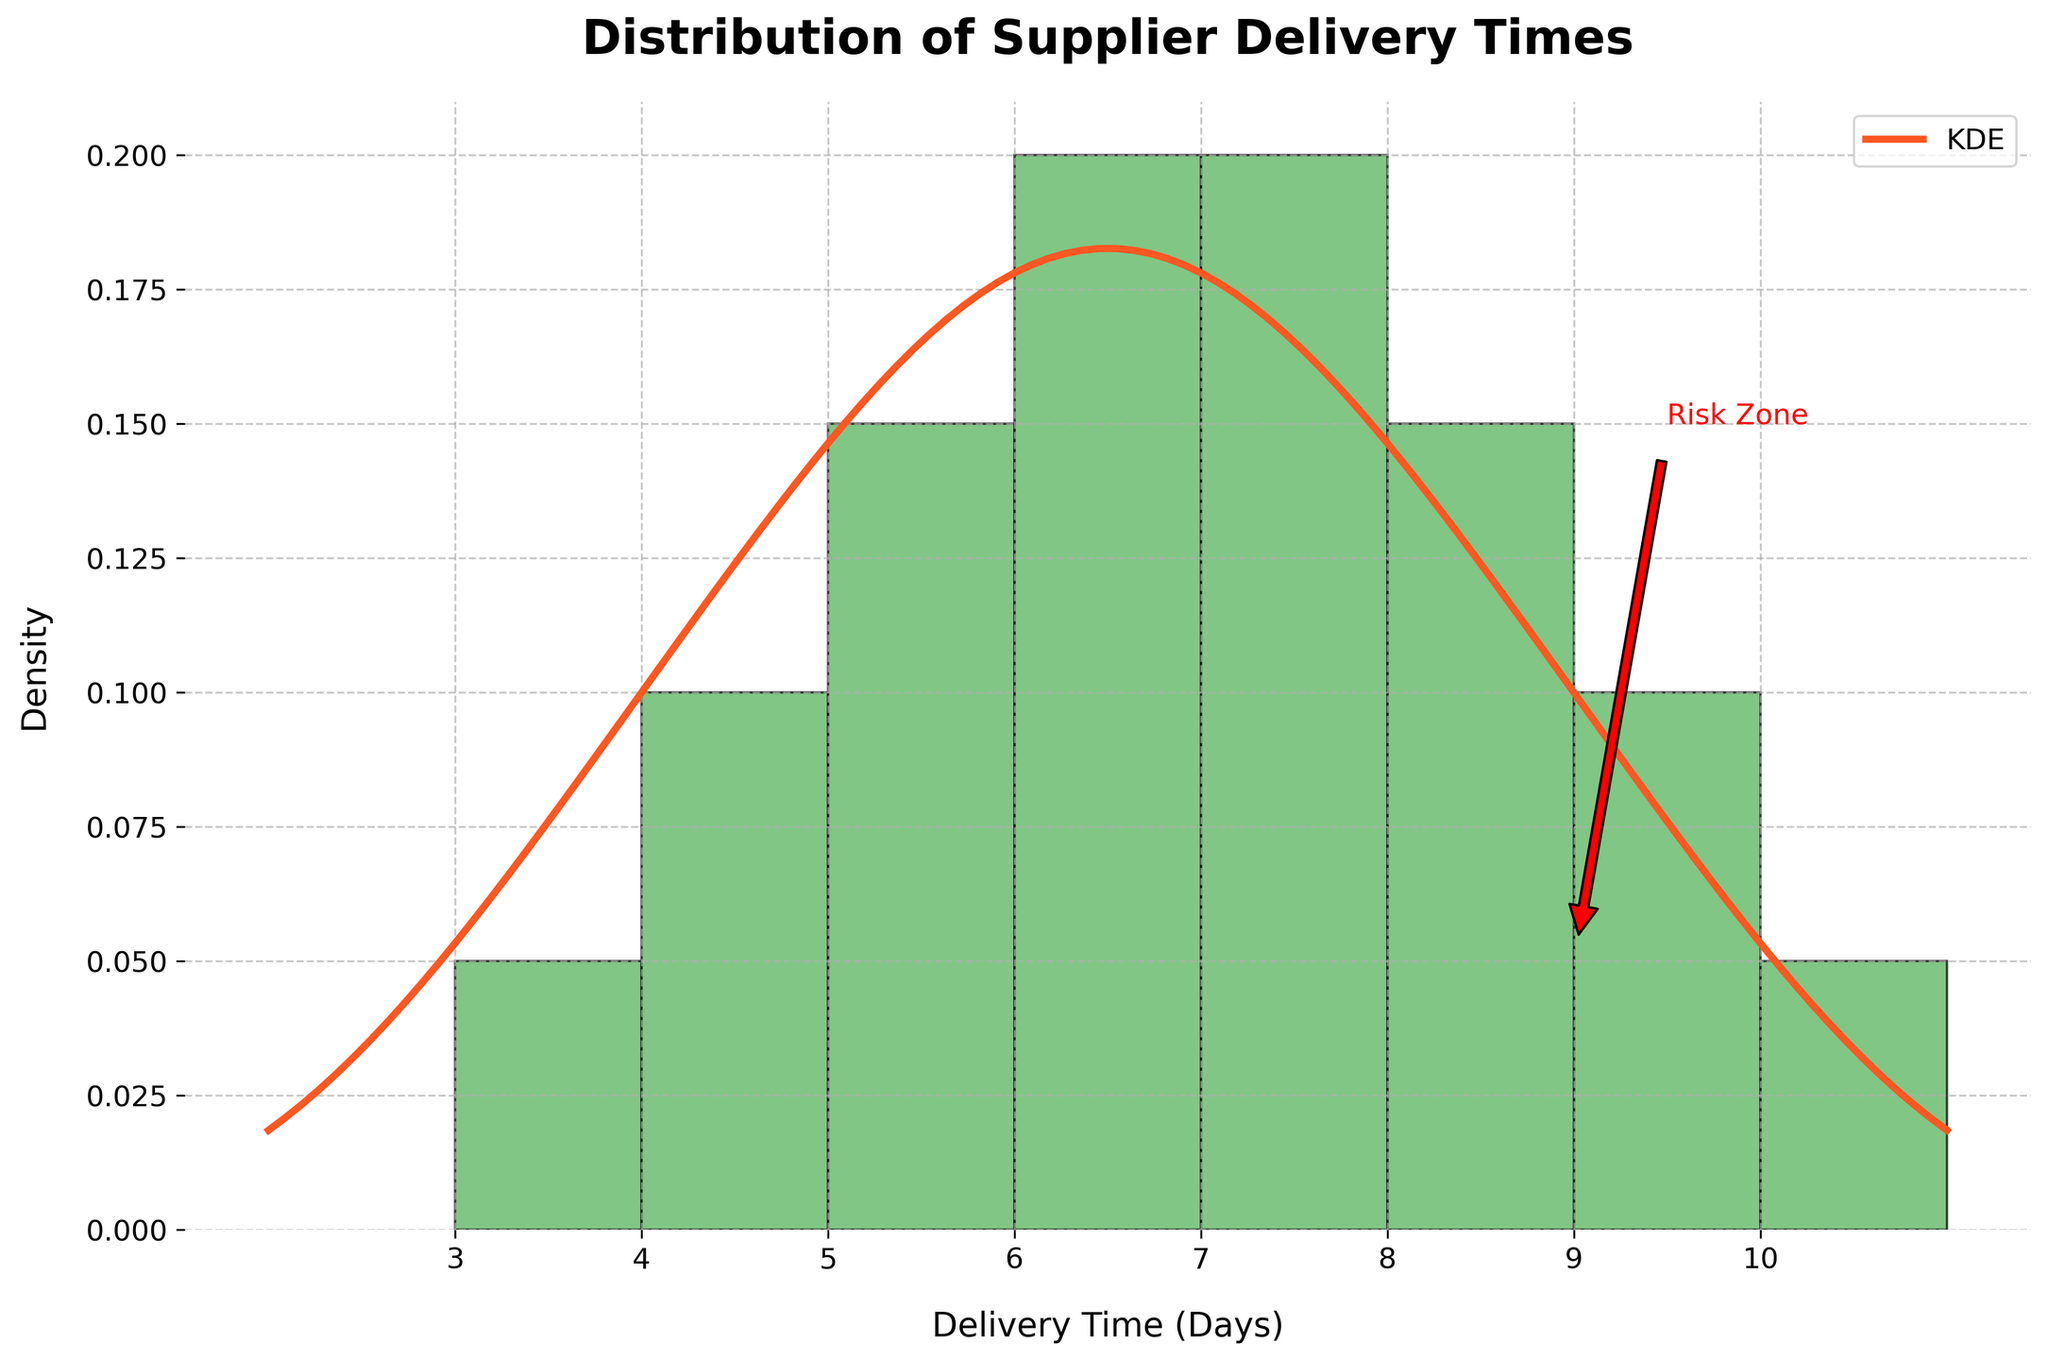What is the title of the figure? The title is displayed at the top of the figure and usually provides a summary of the visualized data. Here, the title is clearly stated.
Answer: Distribution of Supplier Delivery Times How many suppliers have a delivery time of 6 days? By looking at the histogram, you can see the height of the bar corresponding to 6 days on the x-axis. Count the number of deliveries within that bar.
Answer: 4 What does the red line represent in the figure? The red line is the Kernel Density Estimate (KDE), which represents a smoothed estimate of the distribution of delivery times.
Answer: KDE What is the range of delivery times shown on the x-axis? The x-axis labels will indicate the range of delivery times from the minimum to the maximum value.
Answer: 3 to 10 days Which delivery time corresponds to the highest density according to the KDE curve? To determine the highest density point, identify the peak of the red KDE line.
Answer: 6 days What is annotated as the 'Risk Zone' in the figure? The annotation 'Risk Zone' is located on the figure, usually indicating a specific region of interest that poses a risk.
Answer: Delivery times of 9 days How many suppliers have delivery times longer than 7 days? Count the bars in the histogram for delivery times greater than 7 days by looking at the bars for 8, 9, and 10 days and summing their heights.
Answer: 5 suppliers How does the density for delivery times of 6 days compare to that of 8 days? Compare the heights of the histogram bars and the KDE line at 6 days and 8 days. The KDE curve will show the smoothed density estimate.
Answer: Density at 6 days is higher What delivery time has the lowest KDE density? Check the KDE curve and identify the lowest point on the red line over the delivery time range.
Answer: 10 days What is the mean delivery time if it falls within the 'Risk Zone'? Verify the exact delivery time range noted as 'Risk Zone'. If the mean value of delivery times falls within this range, it implies a risk status. Calculate the mean of all delivery times.
Answer: 6.5 days (No, it doesn't) 